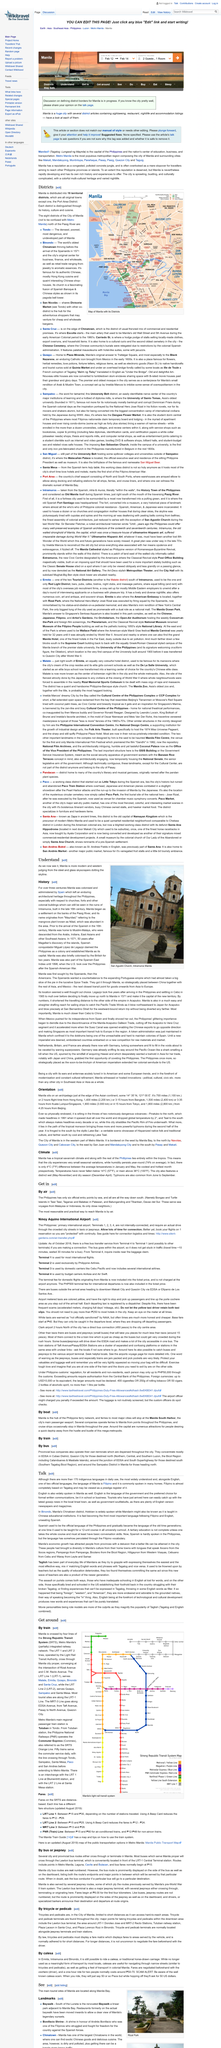Give some essential details in this illustration. Tagalog is the primary language on which Filipino is almost entirely based. January is the coolest month in Manila. May is the hottest month in Manila. Manila, located on the Asian continent, has two active volcanoes that contribute to its unique geography and culture. The average humidity in Manila is approximately 74%. 